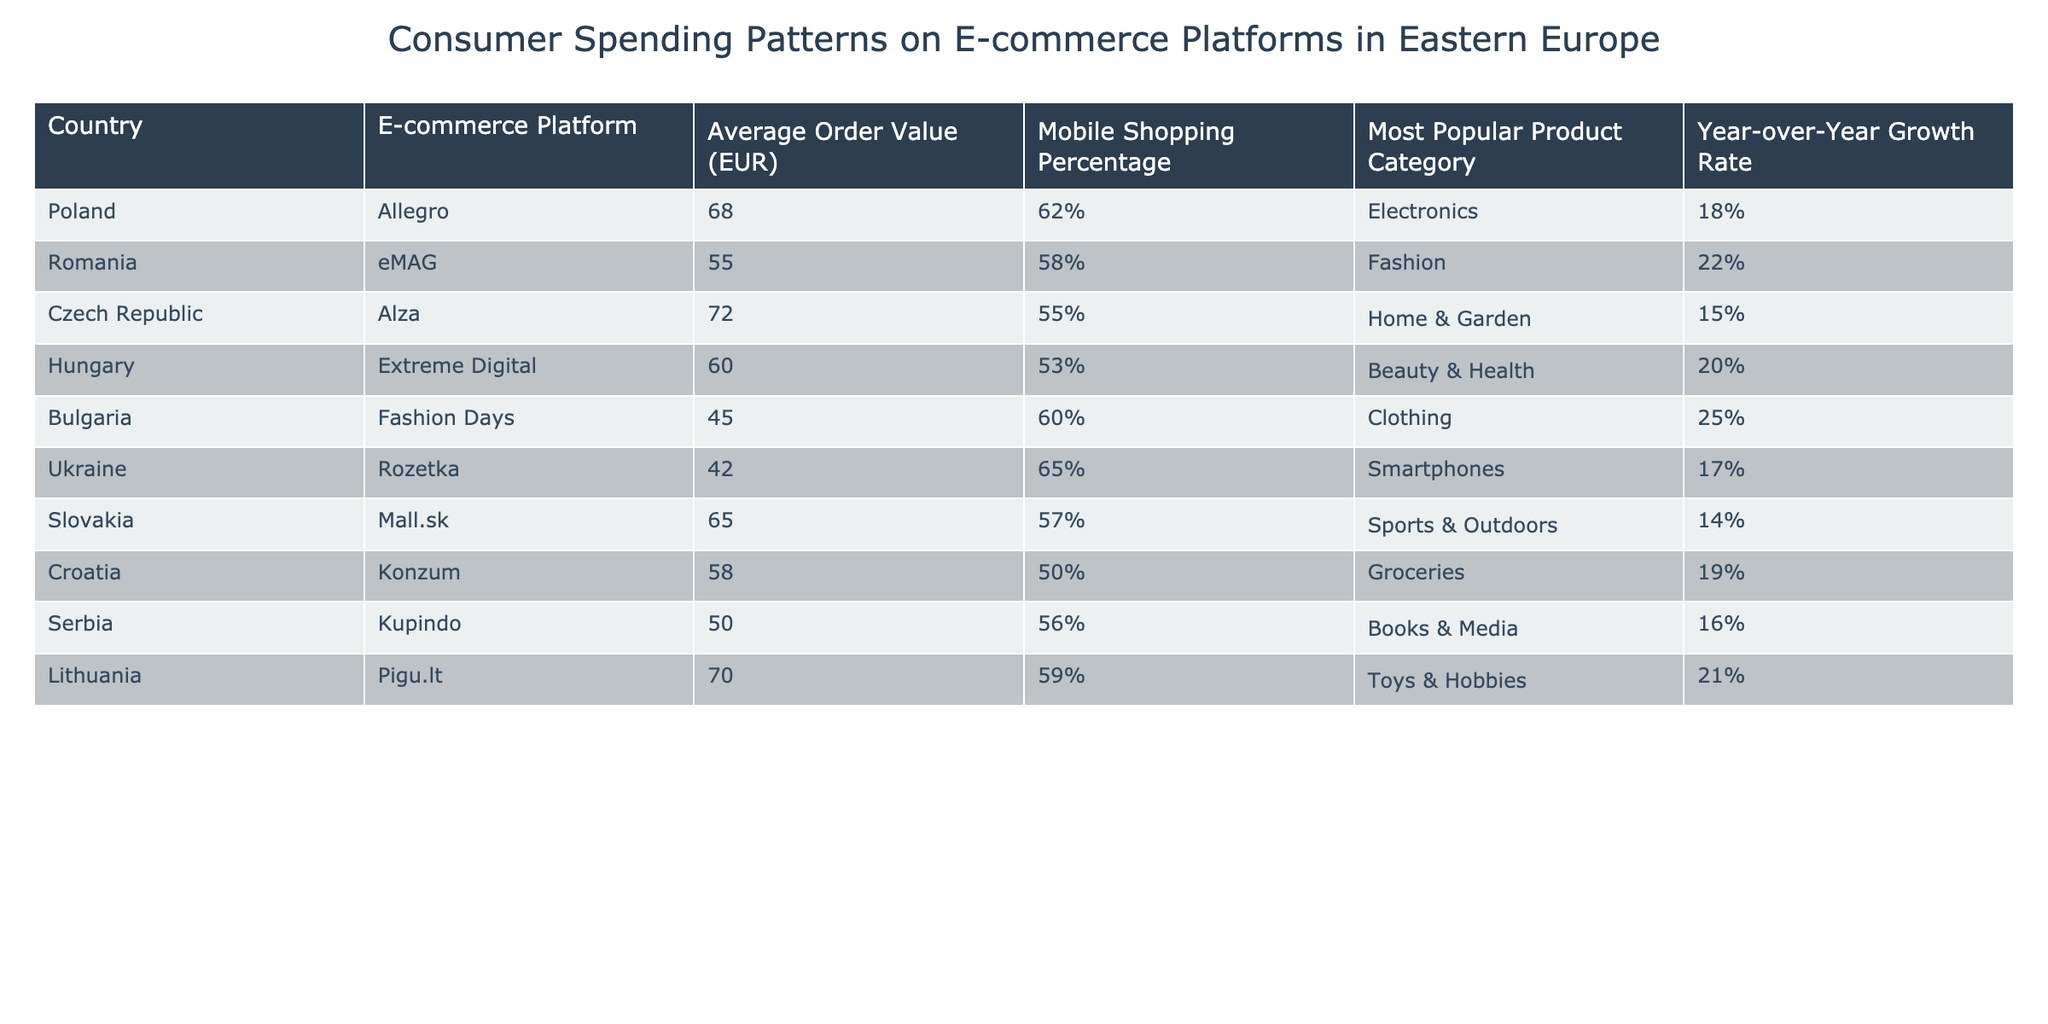What is the average order value across all countries? To find the average order value, we sum all the average order values from the table: (68 + 55 + 72 + 60 + 45 + 42 + 65 + 58 + 50 + 70) =  655. There are 10 countries, so the average order value is 655/10 = 65.5
Answer: 65.5 Which country has the highest average order value and what is it? Reviewing the average order values listed, Poland has the highest value at 68 EUR.
Answer: 68 EUR What product category is most popular in Romania? According to the data, the most popular product category in Romania is Fashion.
Answer: Fashion Is mobile shopping percentage higher in Ukraine or in Slovakia? In Ukraine, the mobile shopping percentage is 65%, while in Slovakia it is 57%. Thus, mobile shopping is higher in Ukraine.
Answer: Yes, it's higher in Ukraine What is the year-over-year growth rate for the e-commerce platform in Bulgaria? The year-over-year growth rate for Fashion Days in Bulgaria is 25%.
Answer: 25% Calculate the difference in average order value between the Czech Republic and Bulgaria. The average order value for the Czech Republic is 72 EUR and for Bulgaria, it is 45 EUR. The difference is 72 - 45 = 27 EUR.
Answer: 27 EUR Which product category has the highest year-over-year growth rate? Reviewing the year-over-year growth rates, Clothing in Bulgaria has the highest growth rate at 25%.
Answer: Clothing In which country does the lowest average order value occur, and what is that value? The lowest average order value is in Ukraine, which is 42 EUR.
Answer: 42 EUR Is the mobile shopping percentage in Poland greater than or equal to 60%? Poland's mobile shopping percentage is 62%, which is greater than 60%.
Answer: Yes If we consider the mobile shopping percentages in Hungary and Lithuania, which one is lower? Hungary has a mobile shopping percentage of 53%, while Lithuania has 59%. Therefore, Hungary's percentage is lower.
Answer: Hungary's is lower 